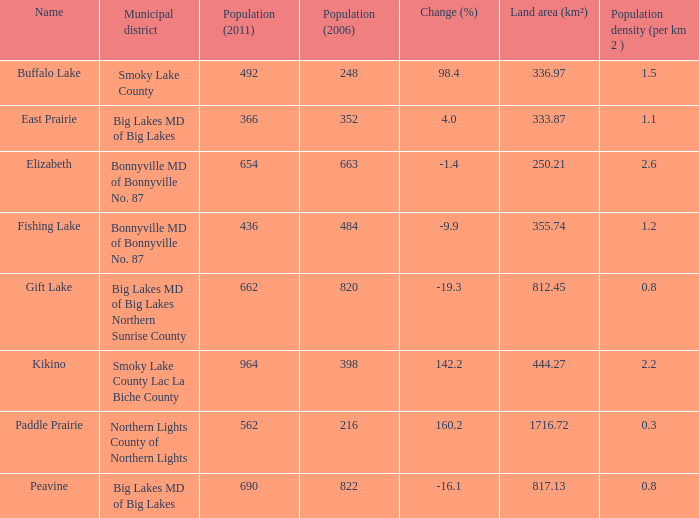At what site does a shift of -1 1.0. 